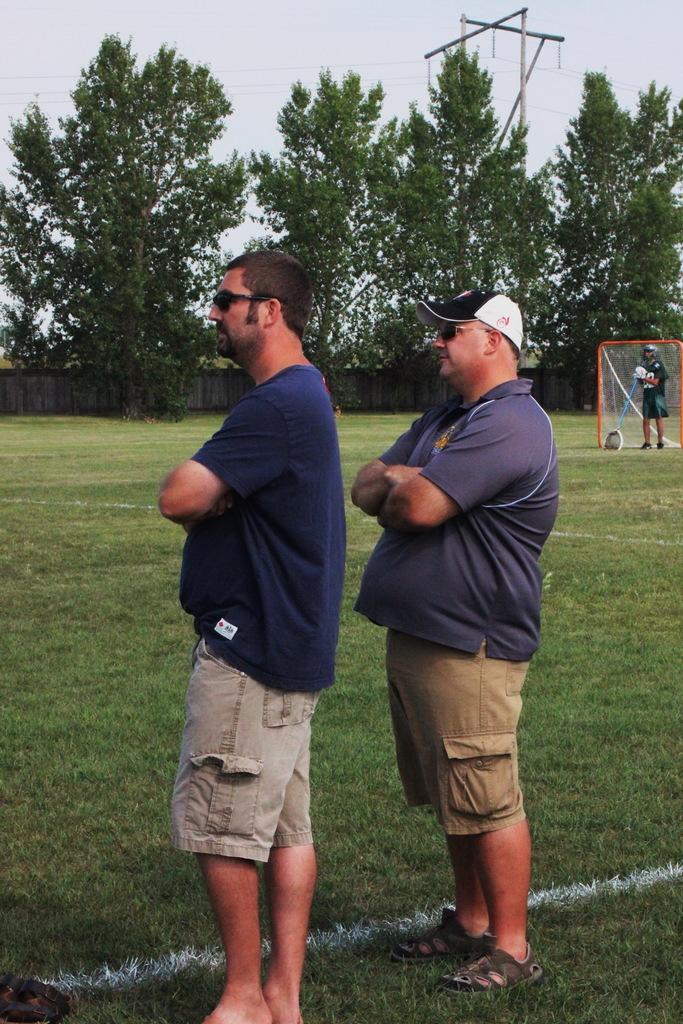Please provide a concise description of this image. In this image I can see two people standing on the ground. These people are wearing the navy blue, brown and ash color dresses. I can see one person with the cap. To the right there is another person holding something and I can see the net. In the background I can see the wall, trees, pole and the sky. 